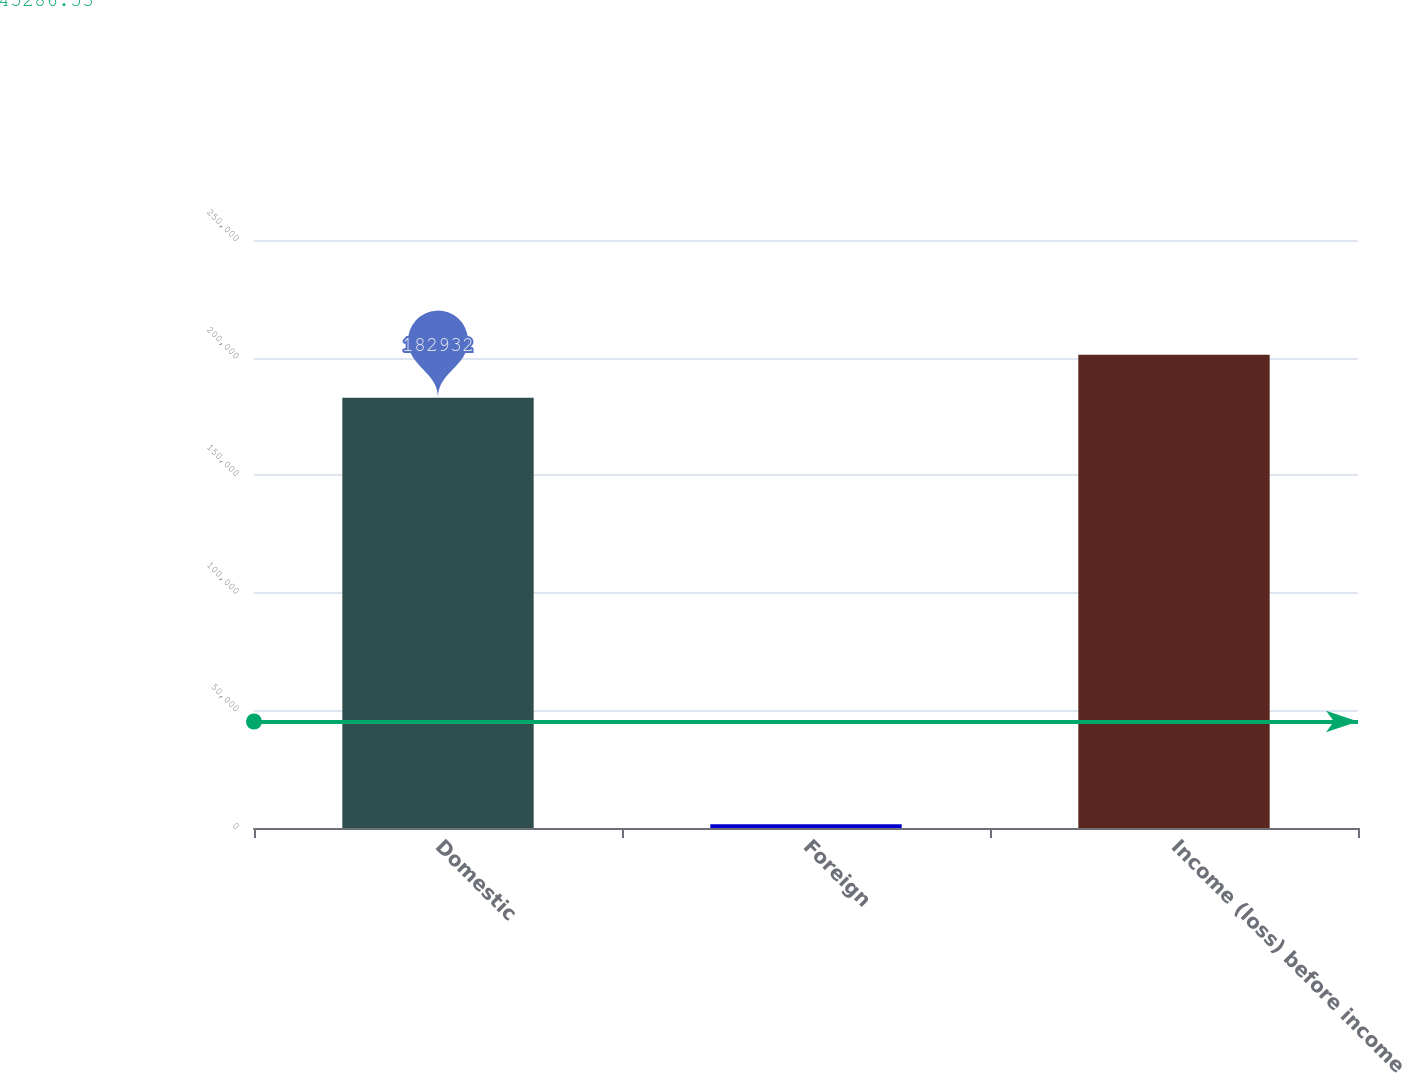Convert chart. <chart><loc_0><loc_0><loc_500><loc_500><bar_chart><fcel>Domestic<fcel>Foreign<fcel>Income (loss) before income<nl><fcel>182932<fcel>1550<fcel>201225<nl></chart> 